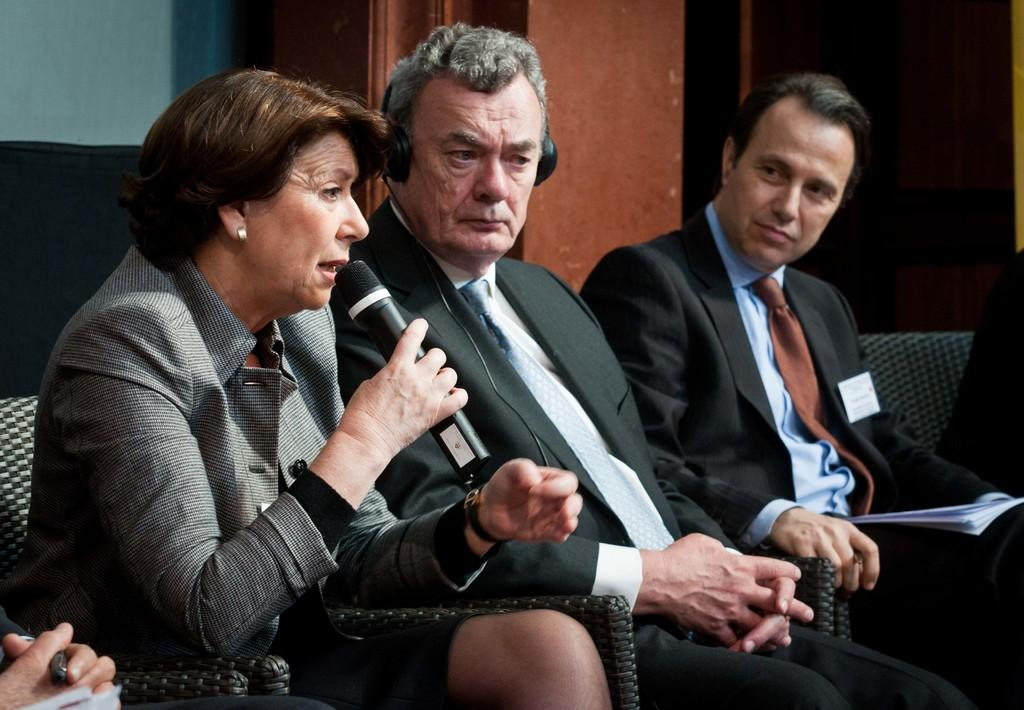What are the people in the image doing? There are people sitting in the image, and some of them are holding microphones, papers, and pens. Can you describe the person holding the microphone? One person is holding a microphone in the image. What might the people holding papers and pens be doing? They might be taking notes or following along with a presentation. What can be seen in the background of the image? There is a wall in the background of the image. What type of bit is being used by the person holding the microphone? There is no bit present in the image, as the person is holding a microphone, not a bit. 